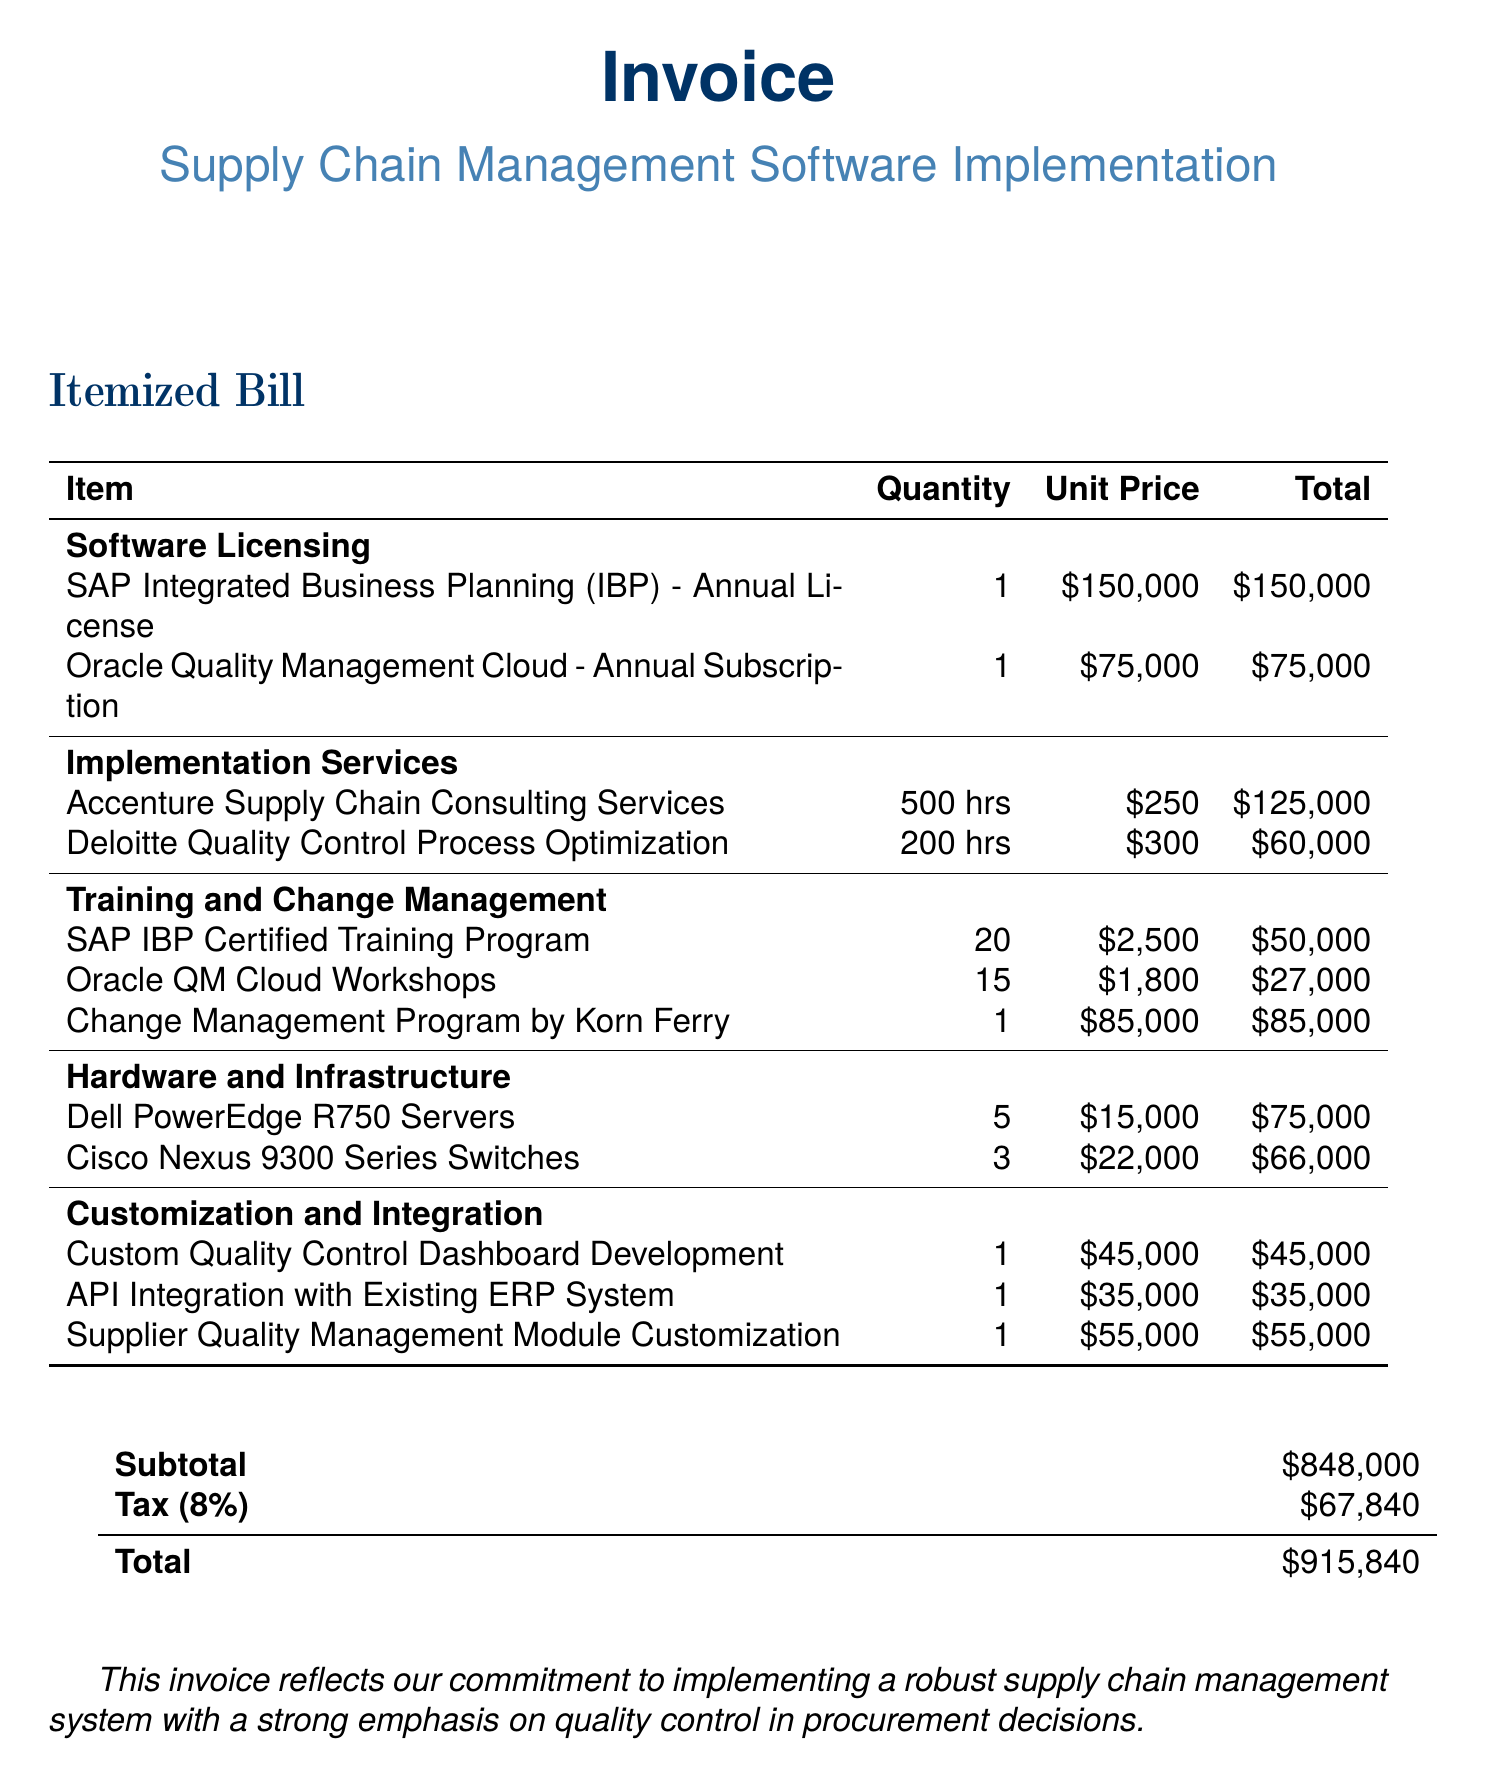what is the total price for the SAP Integrated Business Planning (IBP) annual license? The total price for the SAP Integrated Business Planning (IBP) annual license is stated in the invoice as $150,000.
Answer: $150,000 how many hours of consulting services are included from Accenture? The invoice specifies 500 hours of consulting services from Accenture for implementation and customization.
Answer: 500 hours what is the unit price for the Oracle QM Cloud Workshops? The unit price for the Oracle QM Cloud Workshops is provided in the invoice as $1,800.
Answer: $1,800 what is the subtotal of the invoice before tax? The subtotal before tax is listed as $848,000, which includes all services and licenses.
Answer: $848,000 how much is the tax amount charged on the invoice? The tax amount charged on the invoice is calculated as 8% of the subtotal, which equals $67,840.
Answer: $67,840 what is the total invoiced amount? The total amount on the invoice, after including tax, is stated as $915,840.
Answer: $915,840 what type of training program is included for SAP IBP? The invoice lists a "SAP IBP Certified Training Program" focusing on the software and quality control.
Answer: SAP IBP Certified Training Program how many Dell PowerEdge R750 servers are included in the invoice? The number of Dell PowerEdge R750 servers detailed in the invoice is stated as 5.
Answer: 5 what is the purpose of the "Change Management Program by Korn Ferry"? The invoice describes it as a program tailored to ensure smooth adoption of new quality-focused procurement processes.
Answer: ensure smooth adoption of new quality-focused procurement processes 